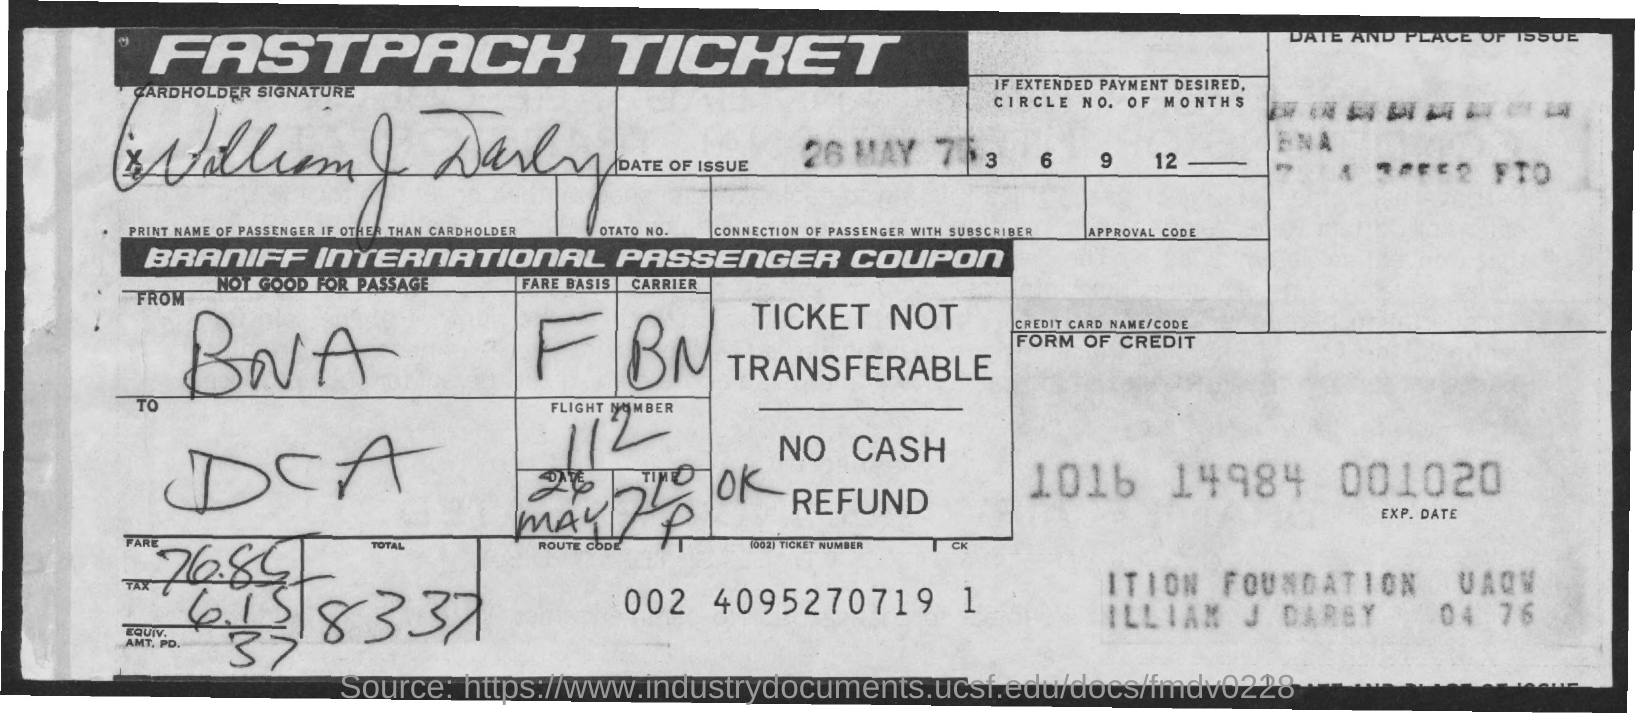Outline some significant characteristics in this image. The tax is 6.15 The date of issue is May 26th, 1975. The flight number is 112. The total is 83.37, rounded to the nearest tenth. The fare is 76.85 dollars. 